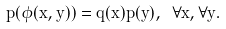<formula> <loc_0><loc_0><loc_500><loc_500>p ( \phi ( x , y ) ) = q ( x ) p ( y ) , \ \forall x , \forall y .</formula> 